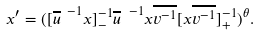<formula> <loc_0><loc_0><loc_500><loc_500>x ^ { \prime } = ( [ { \overline { u } } ^ { \ - 1 } x ] _ { - } ^ { - 1 } { \overline { u } } ^ { \ - 1 } x \overline { v ^ { - 1 } } [ x \overline { v ^ { - 1 } } ] _ { + } ^ { - 1 } ) ^ { \theta } .</formula> 